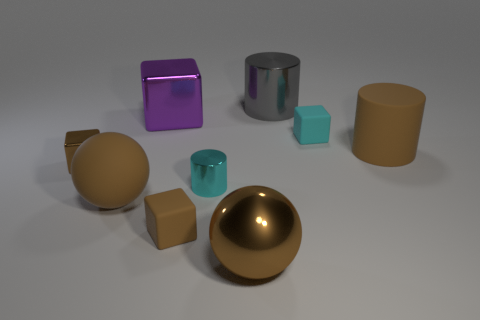There is a brown rubber object behind the small brown shiny thing in front of the tiny cyan thing that is to the right of the big gray metal thing; what is its size?
Your response must be concise. Large. There is a object that is behind the tiny cyan rubber cube and left of the big metallic cylinder; how big is it?
Ensure brevity in your answer.  Large. What shape is the large brown rubber object in front of the brown rubber object that is behind the cyan metal object?
Offer a terse response. Sphere. Are there any other things that are the same color as the big rubber cylinder?
Make the answer very short. Yes. What shape is the tiny thing that is to the left of the purple metal object?
Your response must be concise. Cube. There is a large thing that is in front of the small cylinder and to the right of the large cube; what shape is it?
Your answer should be very brief. Sphere. What number of brown things are small metal cubes or big balls?
Your answer should be very brief. 3. There is a shiny thing behind the big cube; does it have the same color as the matte ball?
Make the answer very short. No. There is a shiny cylinder that is behind the brown rubber object that is right of the gray metal cylinder; what size is it?
Give a very brief answer. Large. There is a brown cylinder that is the same size as the brown metallic ball; what is its material?
Provide a short and direct response. Rubber. 